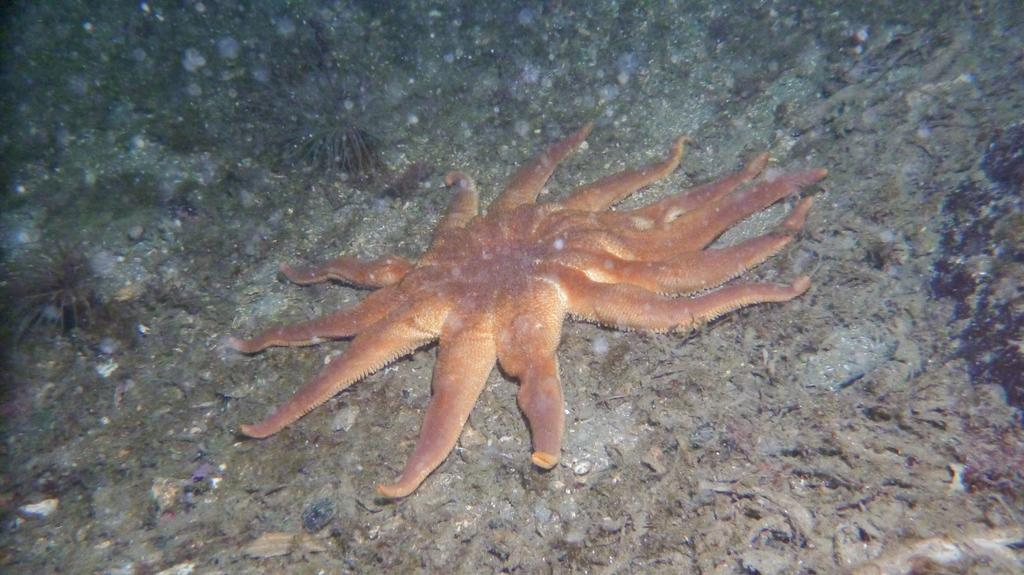What type of sea creature is in the image? There is a starfish in the image. On what surface is the starfish located? The starfish is present on some surface. What type of produce is being sold at the market in the image? There is no market or produce present in the image; it features a starfish on a surface. How many chickens are visible in the image? There are no chickens present in the image. 